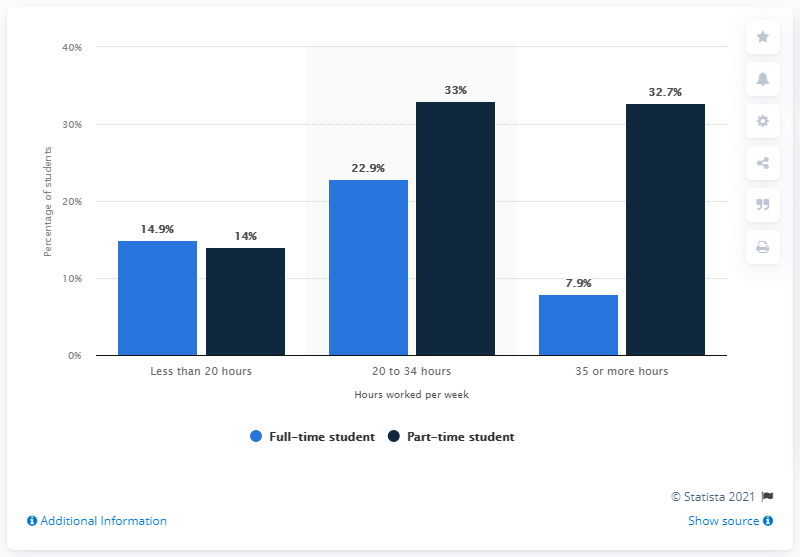Identify some key points in this picture. The difference in the percentage of full-time and part-time students who work less than 20 hours per week is 0.9. The color of the tallest bar is dark blue. According to data from 2017, 14.9% of full-time students at 2-year colleges were employed at that time. 